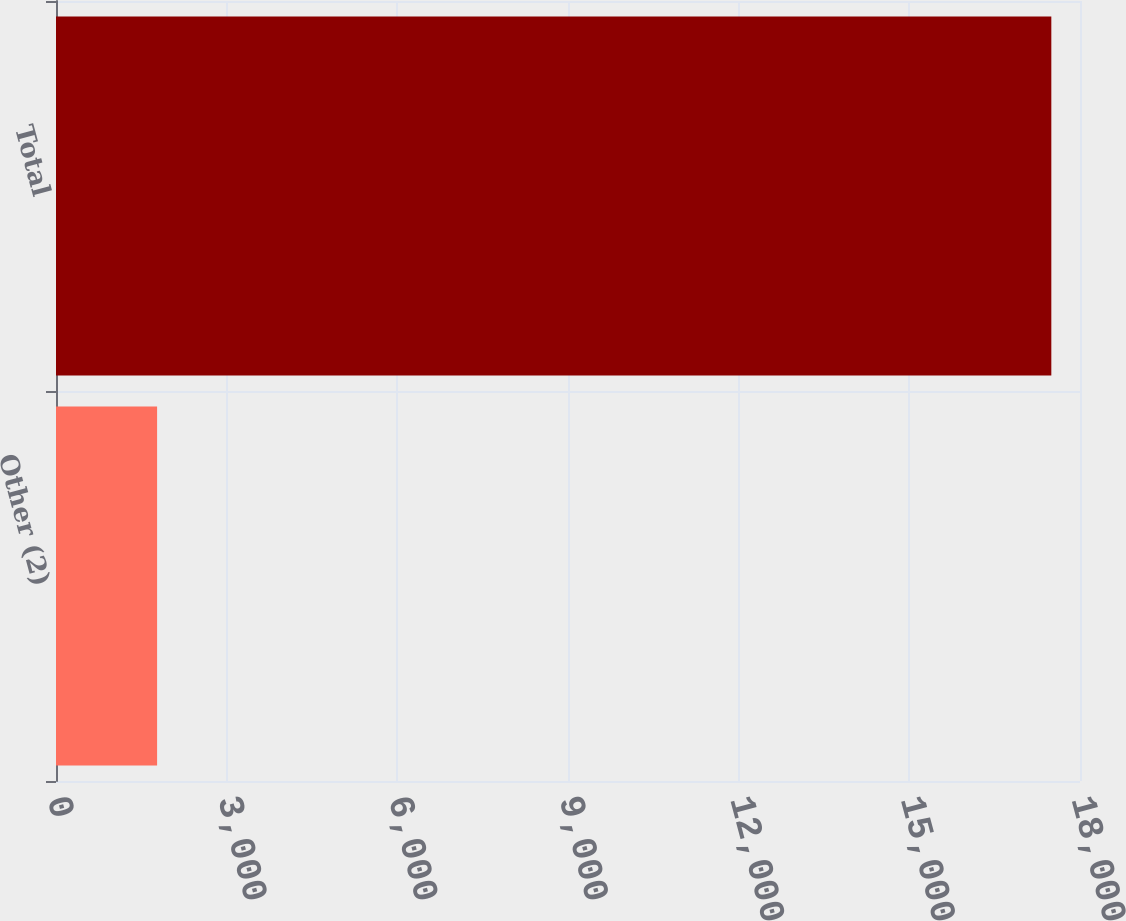Convert chart to OTSL. <chart><loc_0><loc_0><loc_500><loc_500><bar_chart><fcel>Other (2)<fcel>Total<nl><fcel>1777<fcel>17496<nl></chart> 